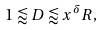<formula> <loc_0><loc_0><loc_500><loc_500>1 \lessapprox D \lessapprox x ^ { \delta } R ,</formula> 